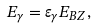<formula> <loc_0><loc_0><loc_500><loc_500>E _ { \gamma } = \varepsilon _ { \gamma } E _ { B Z } ,</formula> 